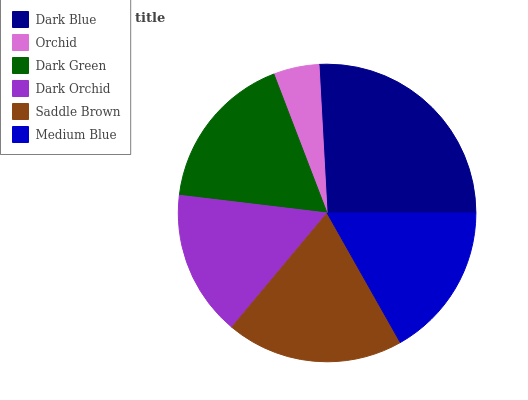Is Orchid the minimum?
Answer yes or no. Yes. Is Dark Blue the maximum?
Answer yes or no. Yes. Is Dark Green the minimum?
Answer yes or no. No. Is Dark Green the maximum?
Answer yes or no. No. Is Dark Green greater than Orchid?
Answer yes or no. Yes. Is Orchid less than Dark Green?
Answer yes or no. Yes. Is Orchid greater than Dark Green?
Answer yes or no. No. Is Dark Green less than Orchid?
Answer yes or no. No. Is Dark Green the high median?
Answer yes or no. Yes. Is Medium Blue the low median?
Answer yes or no. Yes. Is Orchid the high median?
Answer yes or no. No. Is Saddle Brown the low median?
Answer yes or no. No. 